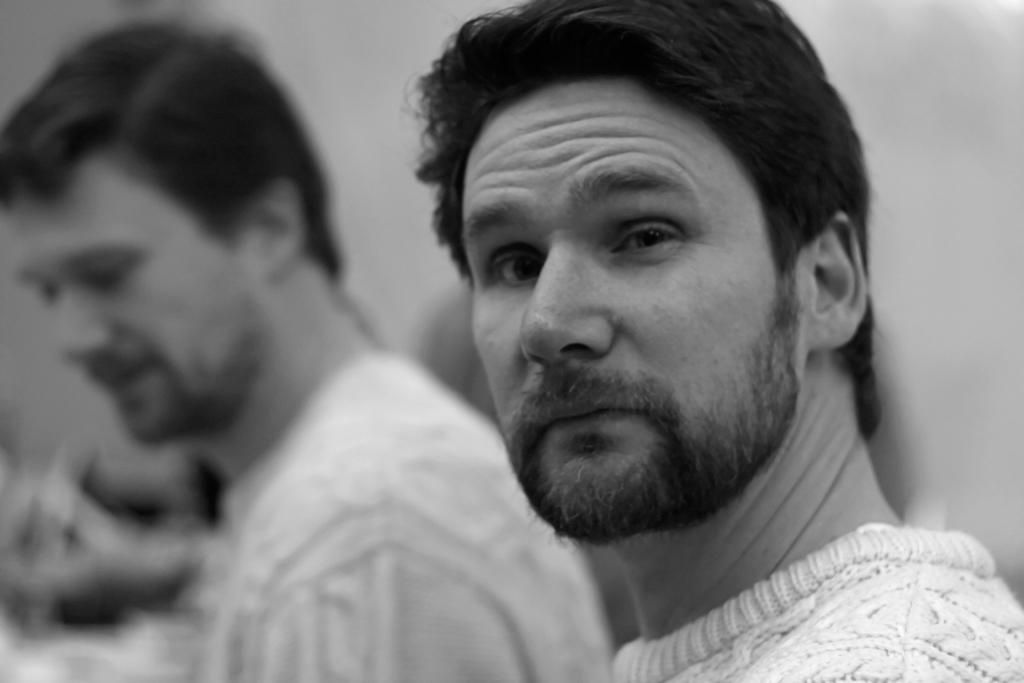Can you describe the people in the image? There is a person on the left side of the image, but they are blurry, and there is a person on the right side of the image. What is the position of the person on the right side of the image? The person on the right side of the image is visible and not blurry. How many dolls are sitting on the pump in the image? There are no dolls or pumps present in the image. 